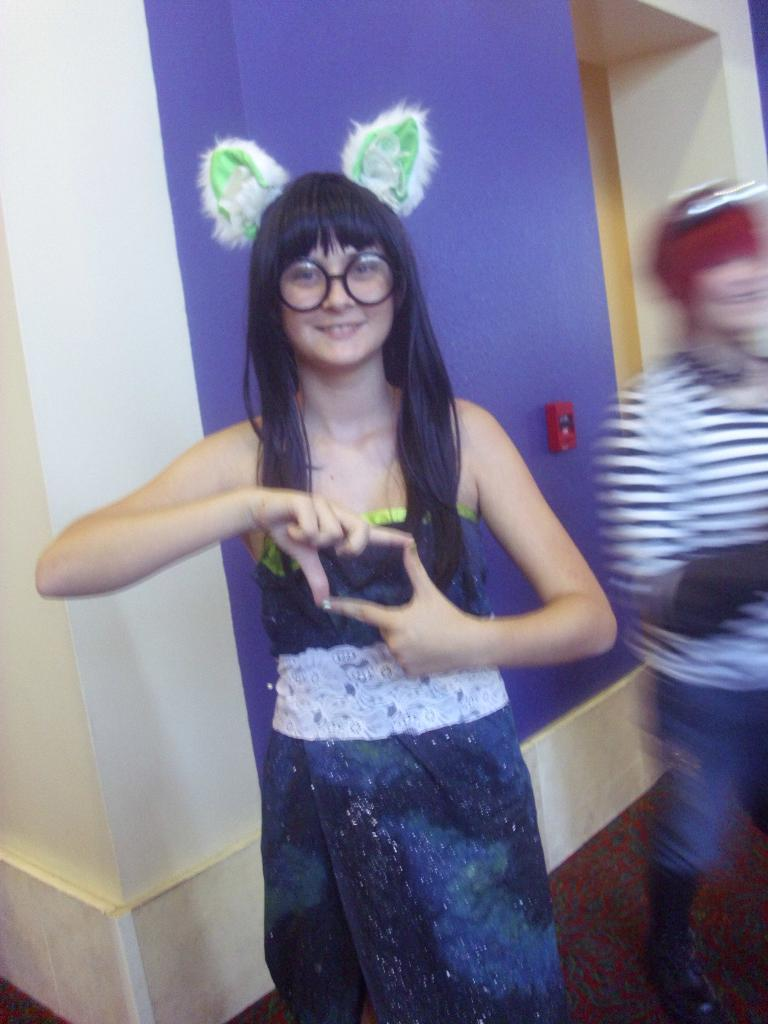What are the people in the image doing? The persons standing on the floor in the image are likely standing or posing for the picture. What can be seen in the background of the image? In the background of the image, there is a power notch and walls. How many elbows can be seen in the image? There is no mention of elbows in the image, so it is impossible to determine how many can be seen. 